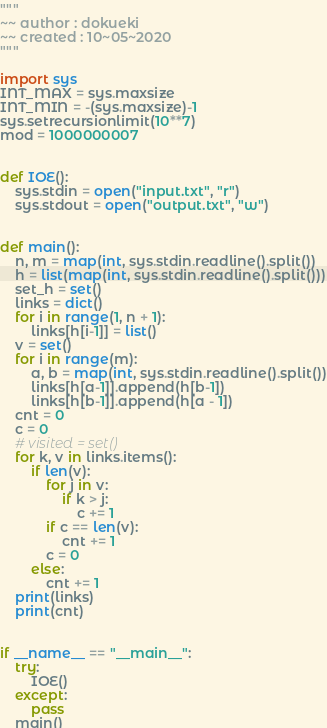Convert code to text. <code><loc_0><loc_0><loc_500><loc_500><_Python_>"""
~~ author : dokueki
~~ created : 10~05~2020
"""

import sys
INT_MAX = sys.maxsize
INT_MIN = -(sys.maxsize)-1
sys.setrecursionlimit(10**7)
mod = 1000000007


def IOE():
    sys.stdin = open("input.txt", "r")
    sys.stdout = open("output.txt", "w")


def main():
    n, m = map(int, sys.stdin.readline().split())
    h = list(map(int, sys.stdin.readline().split()))
    set_h = set()
    links = dict()
    for i in range(1, n + 1):
        links[h[i-1]] = list()
    v = set()
    for i in range(m):
        a, b = map(int, sys.stdin.readline().split())
        links[h[a-1]].append(h[b-1])
        links[h[b-1]].append(h[a - 1])
    cnt = 0
    c = 0
    # visited = set()
    for k, v in links.items():
        if len(v):
            for j in v:
                if k > j:
                    c += 1
            if c == len(v):
                cnt += 1
            c = 0
        else:
            cnt += 1
    print(links)
    print(cnt)


if __name__ == "__main__":
    try:
        IOE()
    except:
        pass
    main()
</code> 